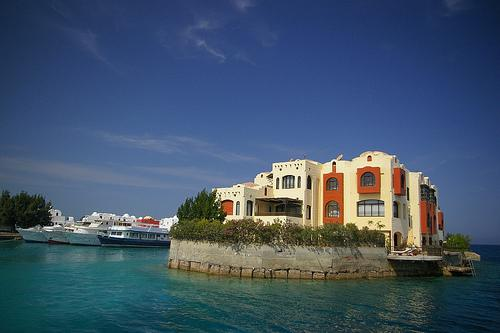Question: how many people are visible?
Choices:
A. Two.
B. Three.
C. None.
D. Four.
Answer with the letter. Answer: C Question: where are the boats?
Choices:
A. Tied at the dock.
B. On the water.
C. By the boathouse.
D. On a trailer.
Answer with the letter. Answer: B Question: where are the clouds?
Choices:
A. Above our heads.
B. Underneath our plane.
C. In the sky.
D. Flying amidst the birds.
Answer with the letter. Answer: C 